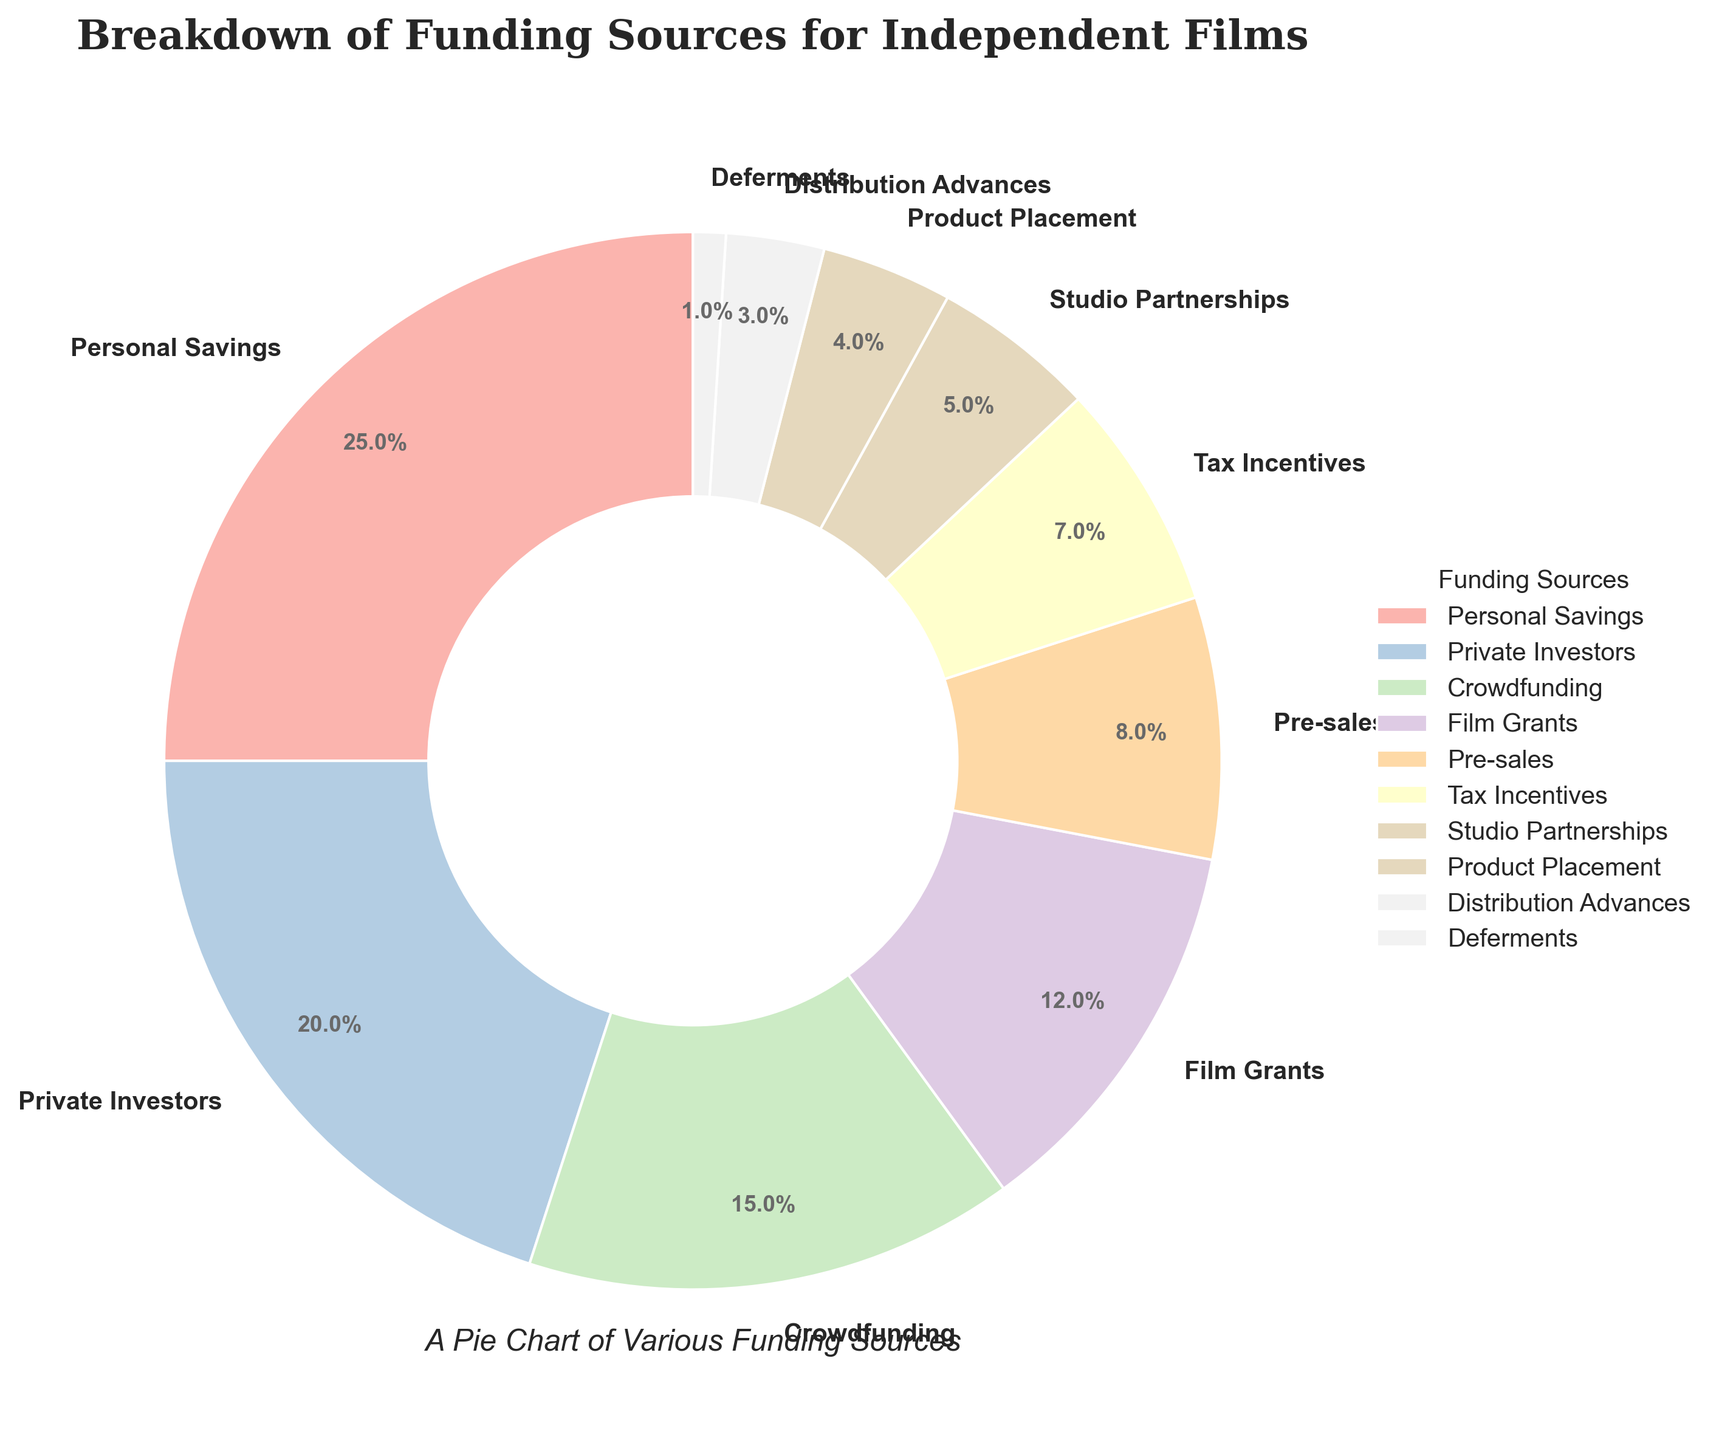What's the largest funding source for independent films, and what percentage does it represent? The pie chart shows various funding sources and their corresponding percentages. The largest section of the pie chart represents "Personal Savings" with 25%.
Answer: Personal Savings, 25% What's the combined percentage of funding from Private Investors and Crowdfunding? To find the combined percentage, add the percentages of Private Investors (20%) and Crowdfunding (15%). So, 20% + 15% = 35%.
Answer: 35% Which funding source contributes less than 5% of the total funding? Look for the slices in the pie chart that represent funding sources with less than 5%. The sources listed are "Product Placement" (4%), "Distribution Advances" (3%), and "Deferments" (1%).
Answer: Product Placement, Distribution Advances, Deferments Which funding sources, if combined, equal exactly 15% of the total funding? To find this, look at the provided percentages and find a combination that sums to 15%. The category "Crowdfunding" alone amounts to 15%.
Answer: Crowdfunding How much more percentage does Film Grants provide compared to Pre-sales? Look at the values for Film Grants (12%) and Pre-sales (8%). Subtract Pre-sales from Film Grants to get 12% - 8% = 4%.
Answer: 4% What is the difference between the highest and lowest funding percentages? Identify the highest percentage (Personal Savings at 25%) and the lowest percentage (Deferments at 1%). Subtract the lowest from the highest: 25% - 1% = 24%.
Answer: 24% Which visual elements (e.g., color or slice size) indicate the funding sources of Tax Incentives and Studio Partnerships? The pie chart uses different colors for each category, and the size of each slice also represents the percentage. Tax Incentives (7%) is represented by a medium-sized slice, and Studio Partnerships (5%) is slightly smaller.
Answer: Slice size and color If you were to combine the percentages of the smallest three funding categories, what would be the total? Sum the percentages of the smallest three categories: "Deferments" (1%), "Distribution Advances" (3%), and "Product Placement" (4%). So, 1% + 3% + 4% = 8%.
Answer: 8% Which funding source has a percentage half that of Private Investors? Private Investors have a percentage of 20%. The category that has half of this percentage is 10%. There is no exact 10%, but the closest lower value is "Tax Incentives" with 7%.
Answer: No exact half, closest is Tax Incentives with 7% What is the average percentage of funding sources above 10%? To find the average, sum the percentages of categories above 10%: Personal Savings (25%), Private Investors (20%), and Crowdfunding (15%), Film Grants (12%). So, 25% + 20% + 15% + 12% = 72%. Divide by the number of categories: 72% / 4 = 18%.
Answer: 18% 